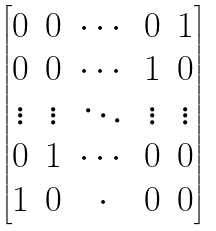Convert formula to latex. <formula><loc_0><loc_0><loc_500><loc_500>\begin{bmatrix} 0 & 0 & \cdots & 0 & 1 \\ 0 & 0 & \cdots & 1 & 0 \\ \vdots & \vdots & \ddots & \vdots & \vdots \\ 0 & 1 & \cdots & 0 & 0 \\ 1 & 0 & \cdot & 0 & 0 \end{bmatrix}</formula> 